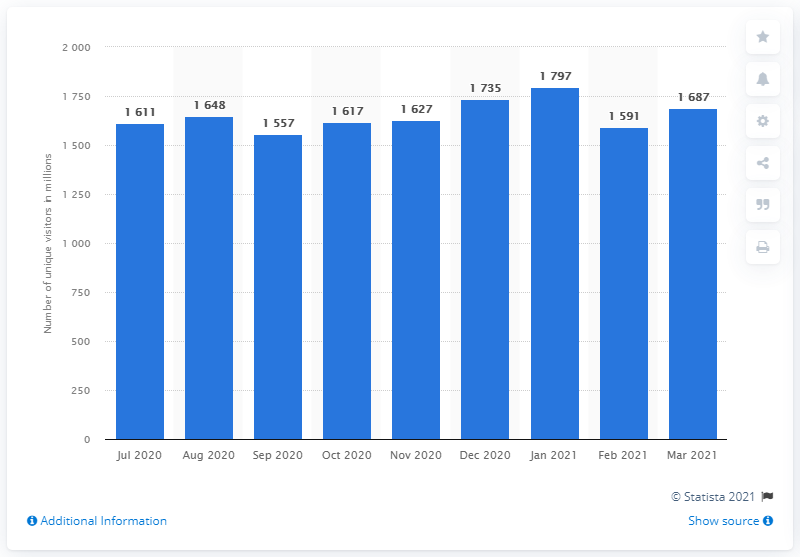Mention a couple of crucial points in this snapshot. In December of 2020, there were 17,350 people who visited Reddit. 